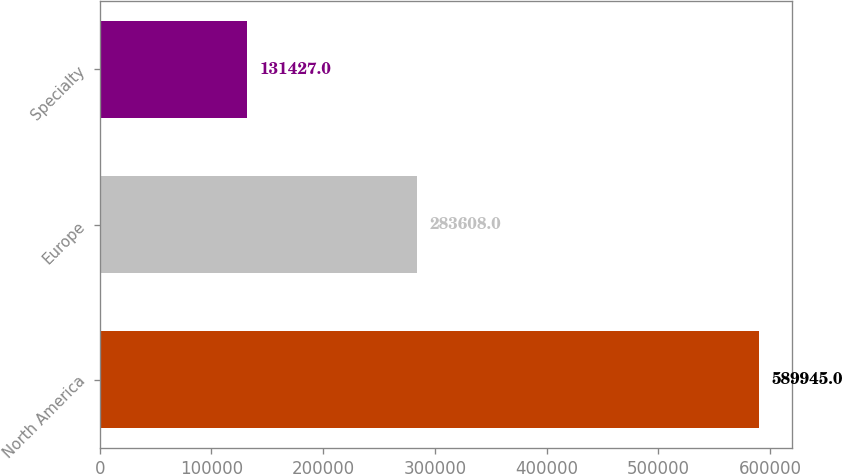<chart> <loc_0><loc_0><loc_500><loc_500><bar_chart><fcel>North America<fcel>Europe<fcel>Specialty<nl><fcel>589945<fcel>283608<fcel>131427<nl></chart> 